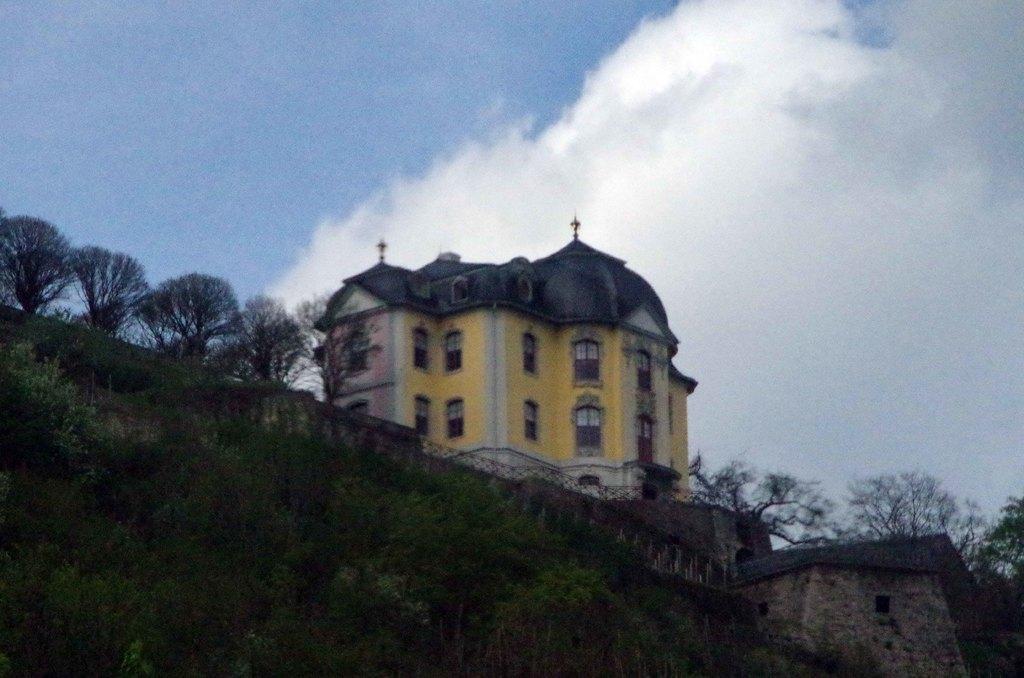In one or two sentences, can you explain what this image depicts? In the center of the image there is a building on the hill. At the bottom of the image we can see trees. In the background we can see trees, sky and clouds. 